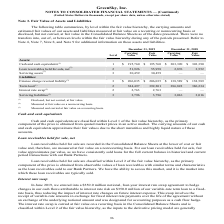According to Greensky's financial document, How was net Loan receivables held for sale measured by the company? at fair value on a nonrecurring basis.. The document states: "(2) Measured at fair value on a nonrecurring basis...." Also, What was the carrying value of the term loan in 2019? According to the financial document, 384,497 (in thousands). The relevant text states: "Term loan (1) 2 384,497 392,201 386,822 386,234..." Also, What was the fair value of the interest rate swap in 2019? According to the financial document, 2,763 (in thousands). The relevant text states: "Interest rate swap (3) 2 2,763 2,763 — —..." Also, How many years did the fair value of Finance charge reversal liability exceed $200,000 thousand? Based on the analysis, there are 1 instances. The counting process: 2019. Also, can you calculate: What was the change in the carrying value of the term loan between 2018 and 2019? Based on the calculation: 384,497-386,822, the result is -2325 (in thousands). This is based on the information: "Term loan (1) 2 384,497 392,201 386,822 386,234 Term loan (1) 2 384,497 392,201 386,822 386,234..." The key data points involved are: 384,497, 386,822. Also, can you calculate: What was the percentage change in the carrying value for Cash and Cash equivalents between 2018 and 2019? To answer this question, I need to perform calculations using the financial data. The calculation is: (195,760-303,390)/303,390, which equals -35.48 (percentage). This is based on the information: "and cash equivalents (1) 1 $ 195,760 $ 195,760 $ 303,390 $ 303,390 Cash and cash equivalents (1) 1 $ 195,760 $ 195,760 $ 303,390 $ 303,390..." The key data points involved are: 195,760, 303,390. 